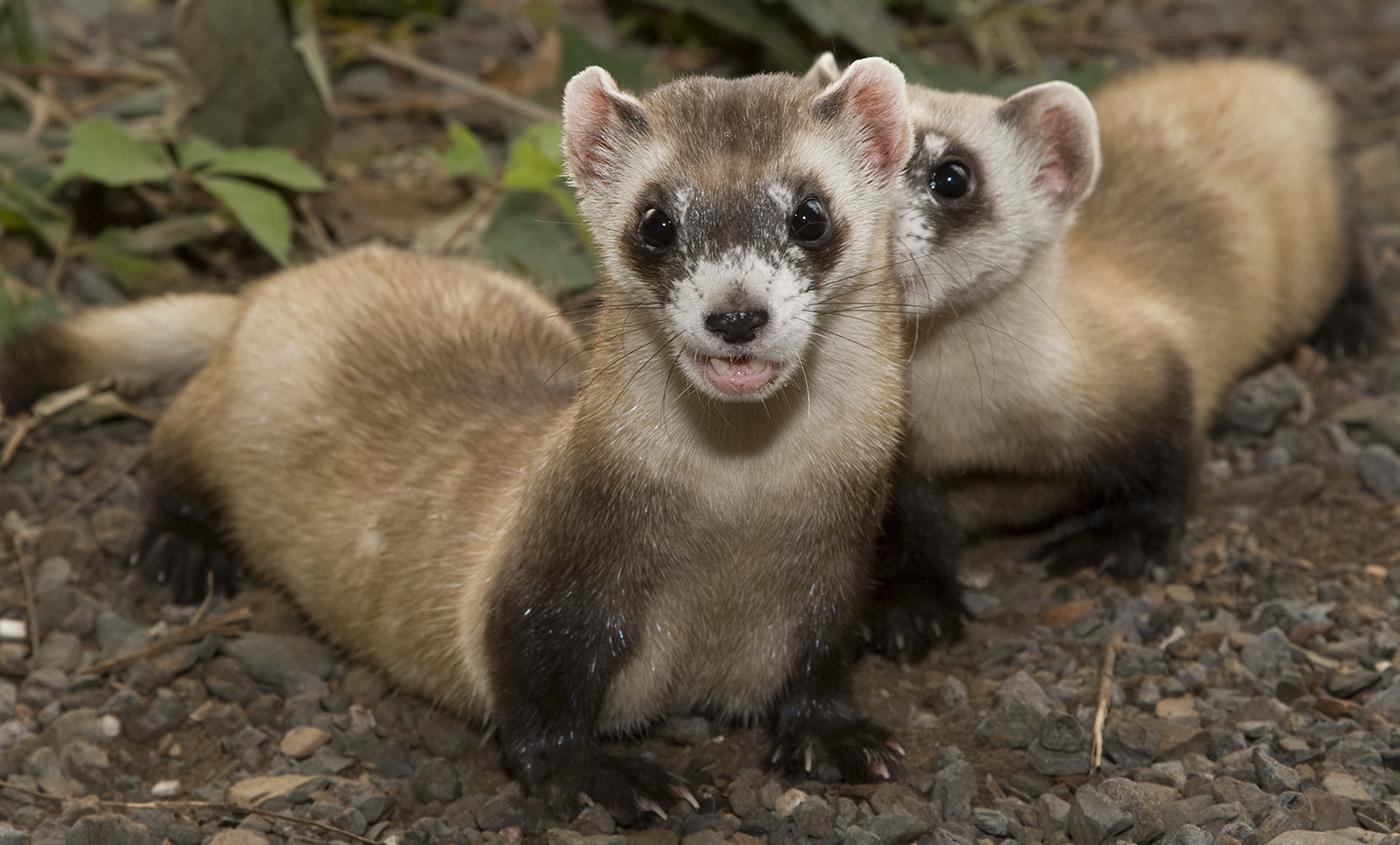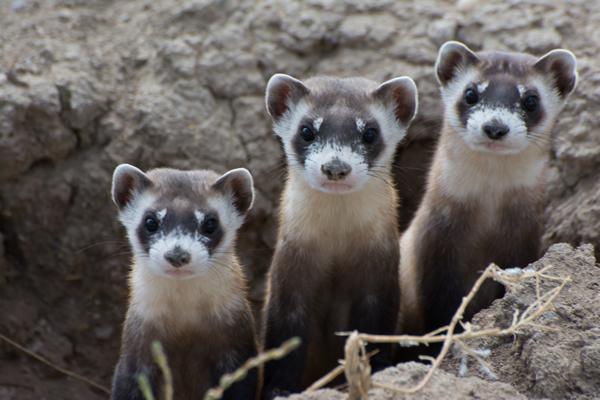The first image is the image on the left, the second image is the image on the right. Evaluate the accuracy of this statement regarding the images: "There are exactly two animals in the image on the left.". Is it true? Answer yes or no. Yes. 